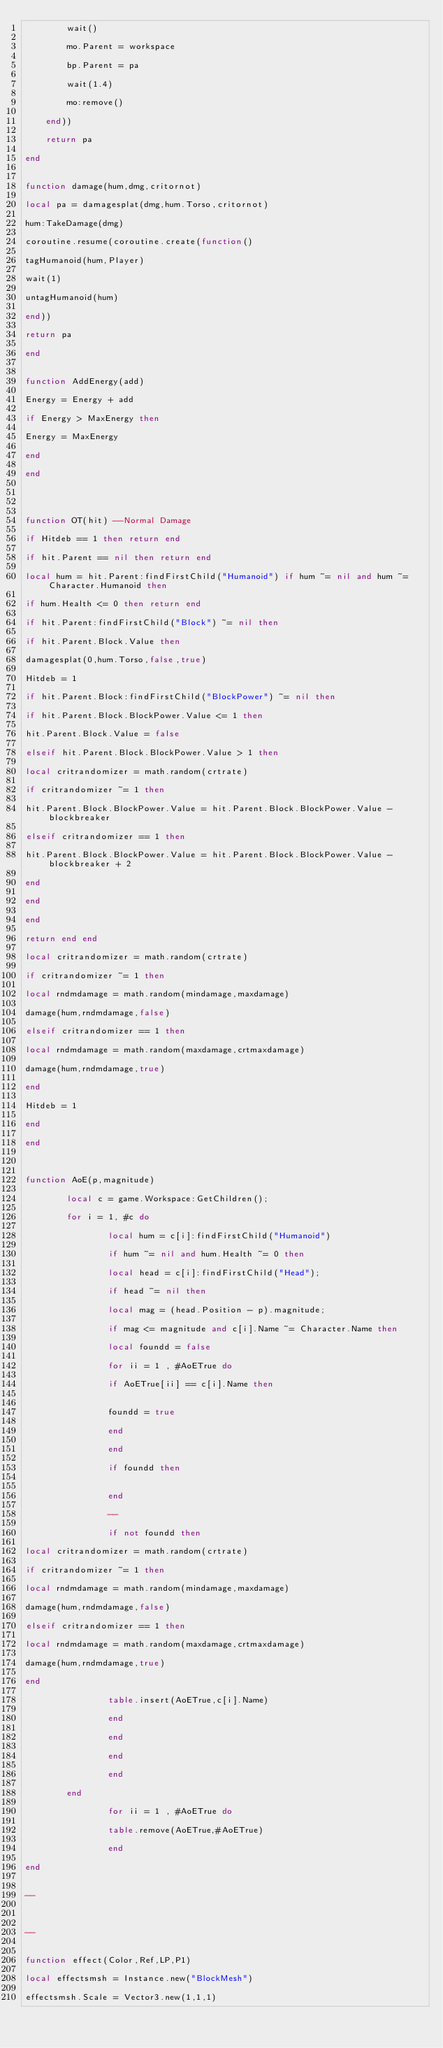<code> <loc_0><loc_0><loc_500><loc_500><_Lua_>        wait()

        mo.Parent = workspace

        bp.Parent = pa

        wait(1.4)

        mo:remove()

    end))

    return pa

end


function damage(hum,dmg,critornot)

local pa = damagesplat(dmg,hum.Torso,critornot)

hum:TakeDamage(dmg)

coroutine.resume(coroutine.create(function()

tagHumanoid(hum,Player)

wait(1)

untagHumanoid(hum)

end))

return pa

end


function AddEnergy(add)

Energy = Energy + add

if Energy > MaxEnergy then

Energy = MaxEnergy

end

end




function OT(hit) --Normal Damage

if Hitdeb == 1 then return end

if hit.Parent == nil then return end

local hum = hit.Parent:findFirstChild("Humanoid") if hum ~= nil and hum ~= Character.Humanoid then

if hum.Health <= 0 then return end

if hit.Parent:findFirstChild("Block") ~= nil then 

if hit.Parent.Block.Value then 

damagesplat(0,hum.Torso,false,true) 

Hitdeb = 1

if hit.Parent.Block:findFirstChild("BlockPower") ~= nil then

if hit.Parent.Block.BlockPower.Value <= 1 then

hit.Parent.Block.Value = false 

elseif hit.Parent.Block.BlockPower.Value > 1 then

local critrandomizer = math.random(crtrate)

if critrandomizer ~= 1 then

hit.Parent.Block.BlockPower.Value = hit.Parent.Block.BlockPower.Value - blockbreaker 

elseif critrandomizer == 1 then

hit.Parent.Block.BlockPower.Value = hit.Parent.Block.BlockPower.Value - blockbreaker + 2

end

end

end

return end end

local critrandomizer = math.random(crtrate)

if critrandomizer ~= 1 then

local rndmdamage = math.random(mindamage,maxdamage)

damage(hum,rndmdamage,false)

elseif critrandomizer == 1 then

local rndmdamage = math.random(maxdamage,crtmaxdamage)

damage(hum,rndmdamage,true)

end

Hitdeb = 1

end

end



function AoE(p,magnitude) 

        local c = game.Workspace:GetChildren();

        for i = 1, #c do

                local hum = c[i]:findFirstChild("Humanoid")

                if hum ~= nil and hum.Health ~= 0 then

                local head = c[i]:findFirstChild("Head");

                if head ~= nil then

                local mag = (head.Position - p).magnitude;

                if mag <= magnitude and c[i].Name ~= Character.Name then

                local foundd = false

                for ii = 1 , #AoETrue do

                if AoETrue[ii] == c[i].Name then


                foundd = true

                end

                end

                if foundd then


                end

                --

                if not foundd then

local critrandomizer = math.random(crtrate)

if critrandomizer ~= 1 then

local rndmdamage = math.random(mindamage,maxdamage)

damage(hum,rndmdamage,false)

elseif critrandomizer == 1 then

local rndmdamage = math.random(maxdamage,crtmaxdamage)

damage(hum,rndmdamage,true)

end

                table.insert(AoETrue,c[i].Name)

                end

                end

                end

                end

        end

                for ii = 1 , #AoETrue do

                table.remove(AoETrue,#AoETrue)

                end

end


--



--


function effect(Color,Ref,LP,P1)

local effectsmsh = Instance.new("BlockMesh")

effectsmsh.Scale = Vector3.new(1,1,1)
</code> 